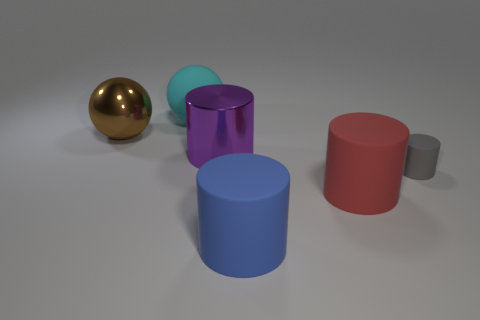Is the material of the purple object the same as the cyan thing?
Make the answer very short. No. Does the metal thing left of the purple shiny object have the same size as the large cyan matte ball?
Ensure brevity in your answer.  Yes. There is a purple metallic cylinder that is in front of the big brown thing; is there a large red matte cylinder that is behind it?
Provide a succinct answer. No. Are there any purple objects made of the same material as the brown object?
Make the answer very short. Yes. There is a thing that is to the right of the big red object to the right of the large blue object; what is its material?
Your response must be concise. Rubber. What is the material of the large thing that is both behind the big red cylinder and in front of the brown metallic ball?
Ensure brevity in your answer.  Metal. Are there the same number of large rubber spheres in front of the big shiny cylinder and big green matte cylinders?
Your response must be concise. Yes. How many other objects have the same shape as the gray rubber object?
Your answer should be very brief. 3. What is the size of the gray matte object that is to the right of the rubber thing that is behind the large sphere in front of the large cyan rubber thing?
Keep it short and to the point. Small. Is the material of the ball to the right of the big metallic ball the same as the red cylinder?
Keep it short and to the point. Yes. 